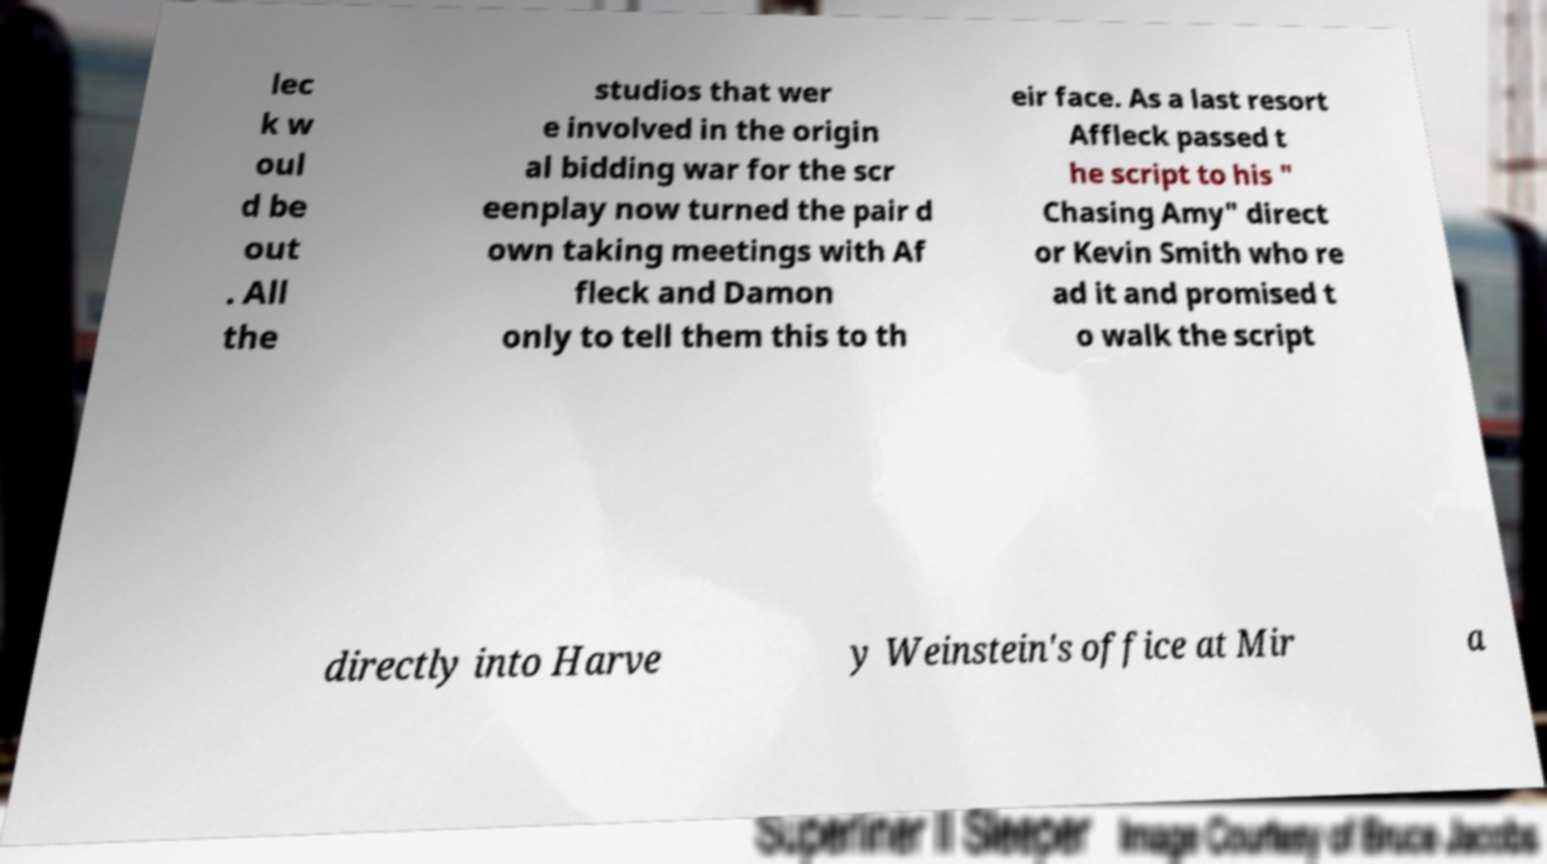There's text embedded in this image that I need extracted. Can you transcribe it verbatim? lec k w oul d be out . All the studios that wer e involved in the origin al bidding war for the scr eenplay now turned the pair d own taking meetings with Af fleck and Damon only to tell them this to th eir face. As a last resort Affleck passed t he script to his " Chasing Amy" direct or Kevin Smith who re ad it and promised t o walk the script directly into Harve y Weinstein's office at Mir a 